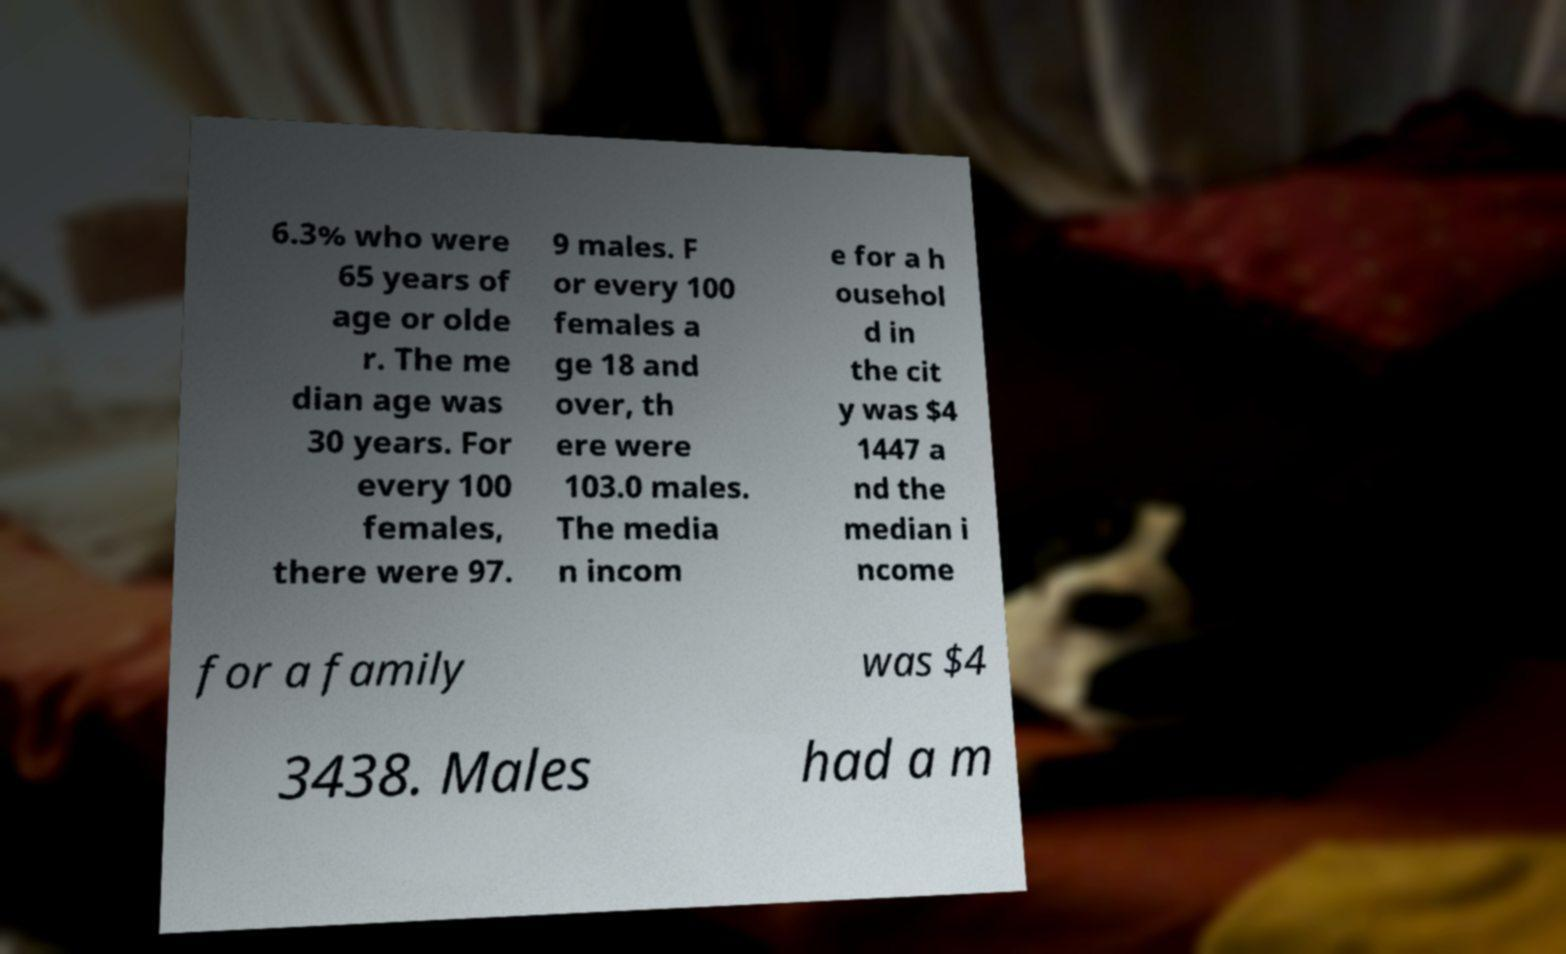I need the written content from this picture converted into text. Can you do that? 6.3% who were 65 years of age or olde r. The me dian age was 30 years. For every 100 females, there were 97. 9 males. F or every 100 females a ge 18 and over, th ere were 103.0 males. The media n incom e for a h ousehol d in the cit y was $4 1447 a nd the median i ncome for a family was $4 3438. Males had a m 